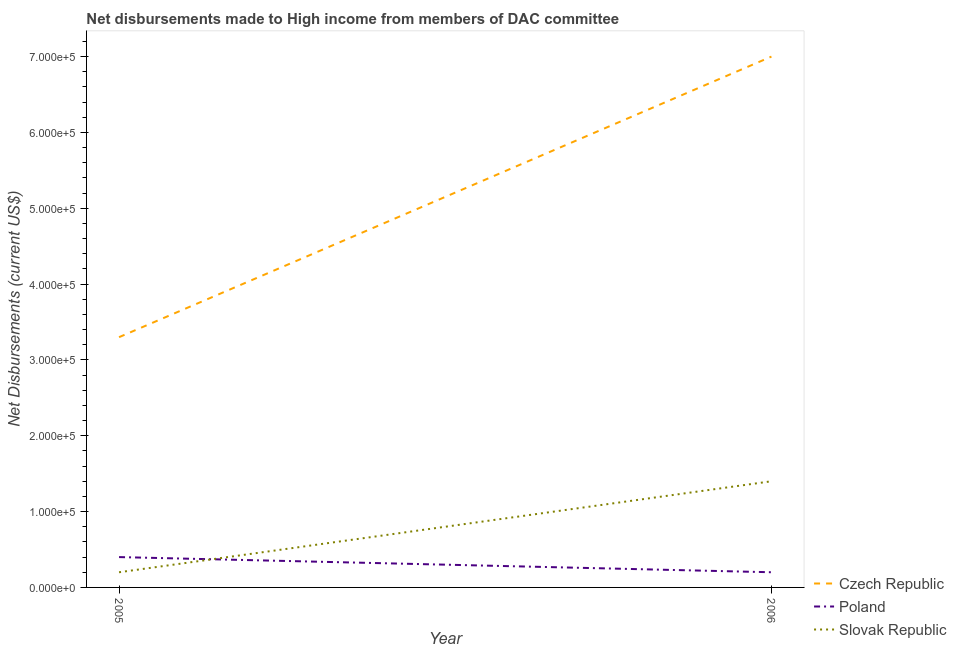How many different coloured lines are there?
Your response must be concise. 3. Is the number of lines equal to the number of legend labels?
Offer a very short reply. Yes. What is the net disbursements made by czech republic in 2006?
Offer a terse response. 7.00e+05. Across all years, what is the maximum net disbursements made by czech republic?
Your answer should be very brief. 7.00e+05. Across all years, what is the minimum net disbursements made by czech republic?
Offer a very short reply. 3.30e+05. In which year was the net disbursements made by slovak republic maximum?
Ensure brevity in your answer.  2006. In which year was the net disbursements made by slovak republic minimum?
Provide a short and direct response. 2005. What is the total net disbursements made by slovak republic in the graph?
Provide a short and direct response. 1.60e+05. What is the difference between the net disbursements made by poland in 2005 and that in 2006?
Give a very brief answer. 2.00e+04. What is the difference between the net disbursements made by poland in 2006 and the net disbursements made by czech republic in 2005?
Offer a terse response. -3.10e+05. In the year 2005, what is the difference between the net disbursements made by poland and net disbursements made by czech republic?
Keep it short and to the point. -2.90e+05. In how many years, is the net disbursements made by poland greater than 300000 US$?
Give a very brief answer. 0. In how many years, is the net disbursements made by slovak republic greater than the average net disbursements made by slovak republic taken over all years?
Provide a succinct answer. 1. Is it the case that in every year, the sum of the net disbursements made by czech republic and net disbursements made by poland is greater than the net disbursements made by slovak republic?
Keep it short and to the point. Yes. Is the net disbursements made by slovak republic strictly greater than the net disbursements made by czech republic over the years?
Your response must be concise. No. What is the difference between two consecutive major ticks on the Y-axis?
Provide a succinct answer. 1.00e+05. Are the values on the major ticks of Y-axis written in scientific E-notation?
Offer a very short reply. Yes. Does the graph contain any zero values?
Your answer should be very brief. No. Does the graph contain grids?
Provide a short and direct response. No. Where does the legend appear in the graph?
Provide a succinct answer. Bottom right. What is the title of the graph?
Your answer should be compact. Net disbursements made to High income from members of DAC committee. Does "Female employers" appear as one of the legend labels in the graph?
Provide a short and direct response. No. What is the label or title of the X-axis?
Keep it short and to the point. Year. What is the label or title of the Y-axis?
Provide a short and direct response. Net Disbursements (current US$). What is the Net Disbursements (current US$) of Czech Republic in 2005?
Provide a succinct answer. 3.30e+05. What is the Net Disbursements (current US$) of Poland in 2005?
Your answer should be very brief. 4.00e+04. What is the Net Disbursements (current US$) of Czech Republic in 2006?
Give a very brief answer. 7.00e+05. What is the Net Disbursements (current US$) of Poland in 2006?
Give a very brief answer. 2.00e+04. What is the Net Disbursements (current US$) of Slovak Republic in 2006?
Offer a very short reply. 1.40e+05. Across all years, what is the maximum Net Disbursements (current US$) of Czech Republic?
Offer a very short reply. 7.00e+05. Across all years, what is the minimum Net Disbursements (current US$) in Czech Republic?
Offer a very short reply. 3.30e+05. Across all years, what is the minimum Net Disbursements (current US$) in Poland?
Offer a very short reply. 2.00e+04. What is the total Net Disbursements (current US$) of Czech Republic in the graph?
Your response must be concise. 1.03e+06. What is the total Net Disbursements (current US$) of Slovak Republic in the graph?
Offer a very short reply. 1.60e+05. What is the difference between the Net Disbursements (current US$) in Czech Republic in 2005 and that in 2006?
Provide a short and direct response. -3.70e+05. What is the difference between the Net Disbursements (current US$) in Poland in 2005 and that in 2006?
Provide a succinct answer. 2.00e+04. What is the difference between the Net Disbursements (current US$) of Czech Republic in 2005 and the Net Disbursements (current US$) of Slovak Republic in 2006?
Provide a short and direct response. 1.90e+05. What is the average Net Disbursements (current US$) of Czech Republic per year?
Keep it short and to the point. 5.15e+05. What is the average Net Disbursements (current US$) in Poland per year?
Offer a very short reply. 3.00e+04. What is the average Net Disbursements (current US$) of Slovak Republic per year?
Your answer should be very brief. 8.00e+04. In the year 2005, what is the difference between the Net Disbursements (current US$) in Czech Republic and Net Disbursements (current US$) in Poland?
Give a very brief answer. 2.90e+05. In the year 2005, what is the difference between the Net Disbursements (current US$) in Czech Republic and Net Disbursements (current US$) in Slovak Republic?
Ensure brevity in your answer.  3.10e+05. In the year 2005, what is the difference between the Net Disbursements (current US$) of Poland and Net Disbursements (current US$) of Slovak Republic?
Your answer should be compact. 2.00e+04. In the year 2006, what is the difference between the Net Disbursements (current US$) of Czech Republic and Net Disbursements (current US$) of Poland?
Keep it short and to the point. 6.80e+05. In the year 2006, what is the difference between the Net Disbursements (current US$) of Czech Republic and Net Disbursements (current US$) of Slovak Republic?
Offer a terse response. 5.60e+05. What is the ratio of the Net Disbursements (current US$) in Czech Republic in 2005 to that in 2006?
Provide a succinct answer. 0.47. What is the ratio of the Net Disbursements (current US$) in Poland in 2005 to that in 2006?
Your answer should be compact. 2. What is the ratio of the Net Disbursements (current US$) of Slovak Republic in 2005 to that in 2006?
Your response must be concise. 0.14. What is the difference between the highest and the second highest Net Disbursements (current US$) in Czech Republic?
Keep it short and to the point. 3.70e+05. What is the difference between the highest and the second highest Net Disbursements (current US$) in Poland?
Give a very brief answer. 2.00e+04. What is the difference between the highest and the second highest Net Disbursements (current US$) of Slovak Republic?
Provide a short and direct response. 1.20e+05. What is the difference between the highest and the lowest Net Disbursements (current US$) of Slovak Republic?
Offer a terse response. 1.20e+05. 